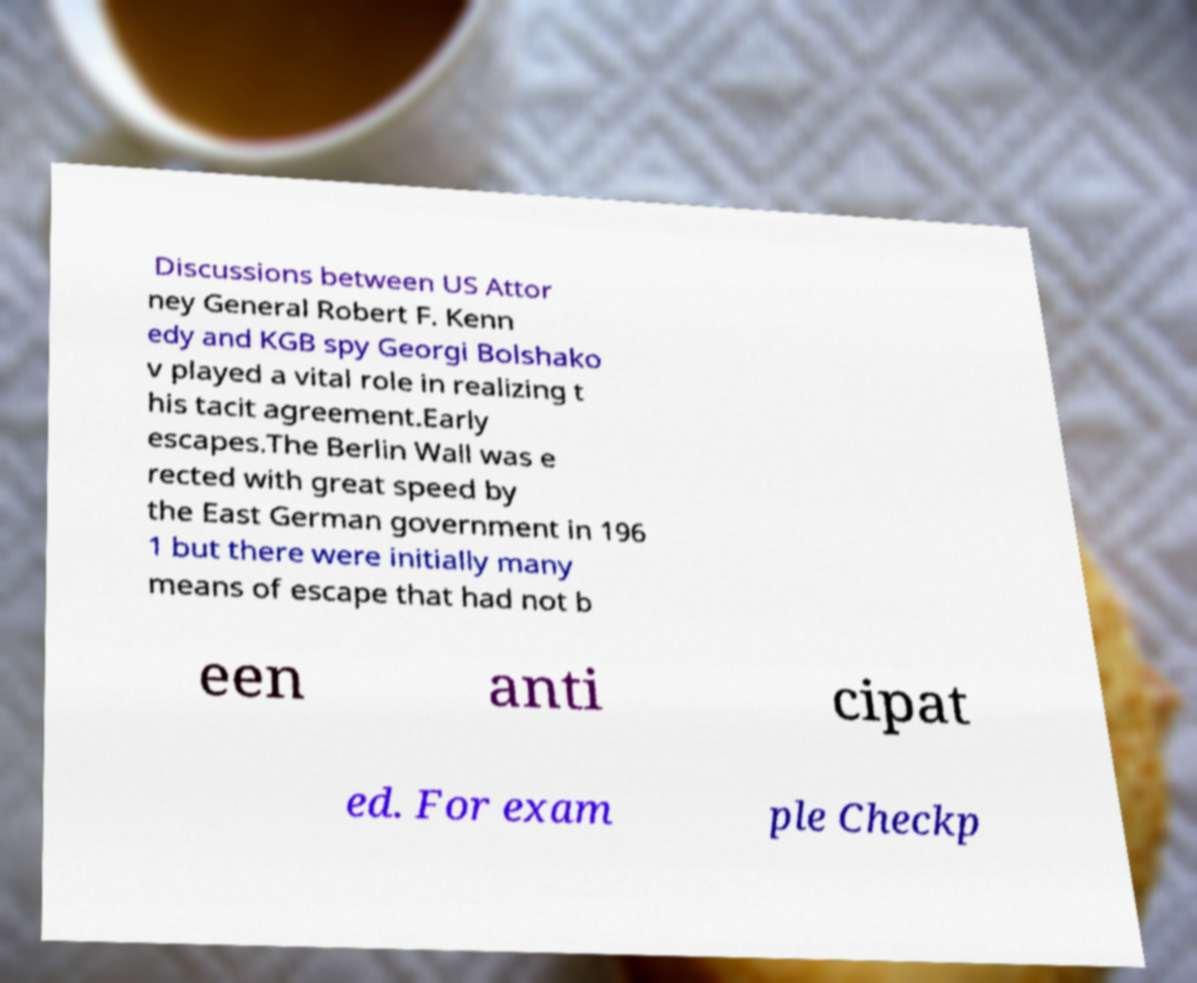I need the written content from this picture converted into text. Can you do that? Discussions between US Attor ney General Robert F. Kenn edy and KGB spy Georgi Bolshako v played a vital role in realizing t his tacit agreement.Early escapes.The Berlin Wall was e rected with great speed by the East German government in 196 1 but there were initially many means of escape that had not b een anti cipat ed. For exam ple Checkp 